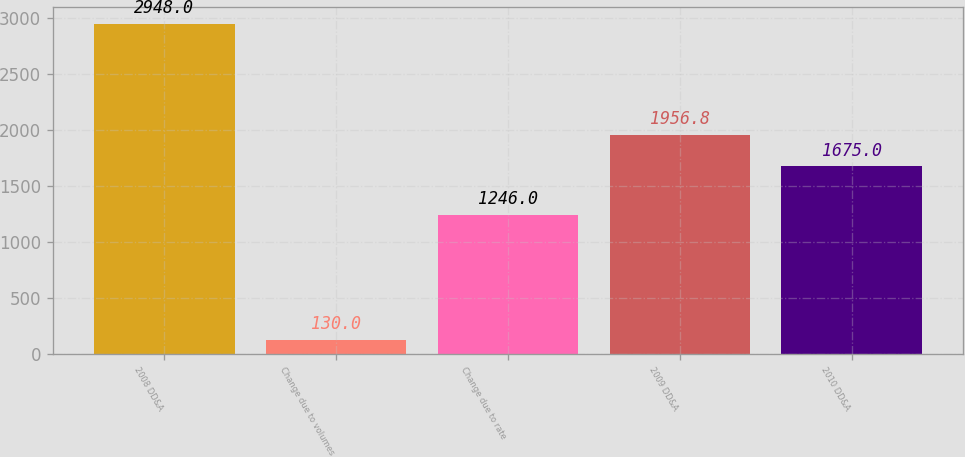<chart> <loc_0><loc_0><loc_500><loc_500><bar_chart><fcel>2008 DD&A<fcel>Change due to volumes<fcel>Change due to rate<fcel>2009 DD&A<fcel>2010 DD&A<nl><fcel>2948<fcel>130<fcel>1246<fcel>1956.8<fcel>1675<nl></chart> 